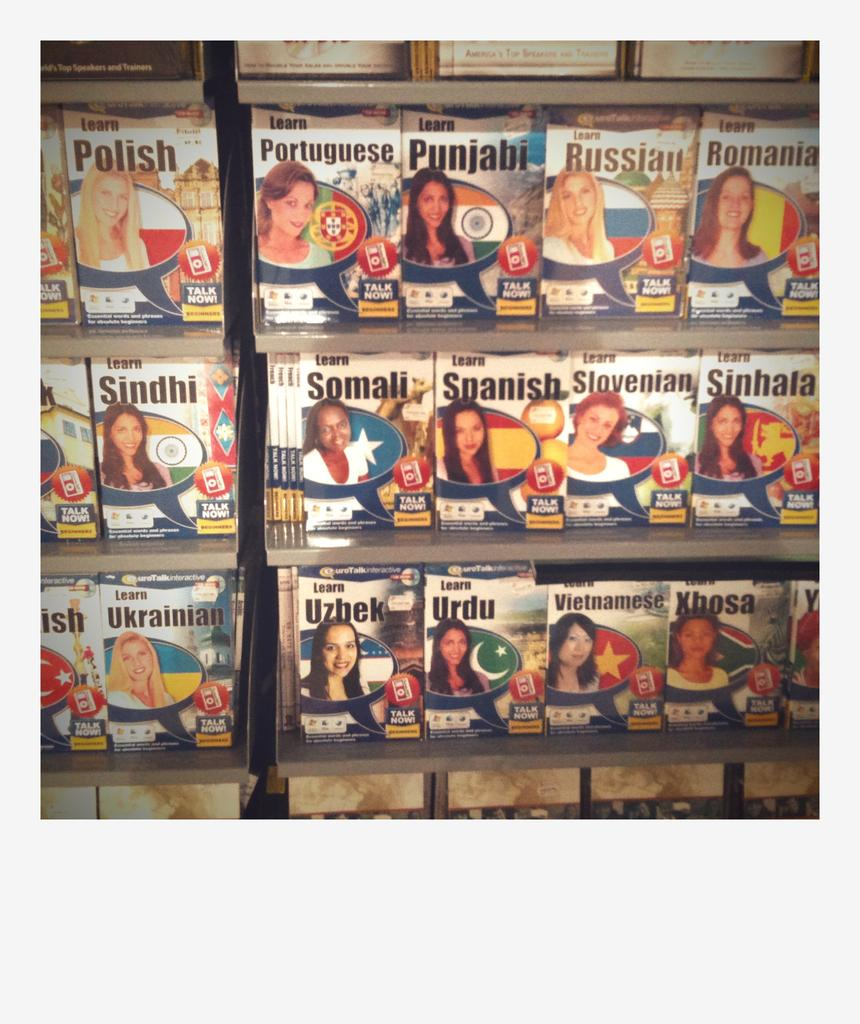<image>
Present a compact description of the photo's key features. Several books for learning languages are on display, such as Somali, Spanish Slovenian, and Sinhala. 